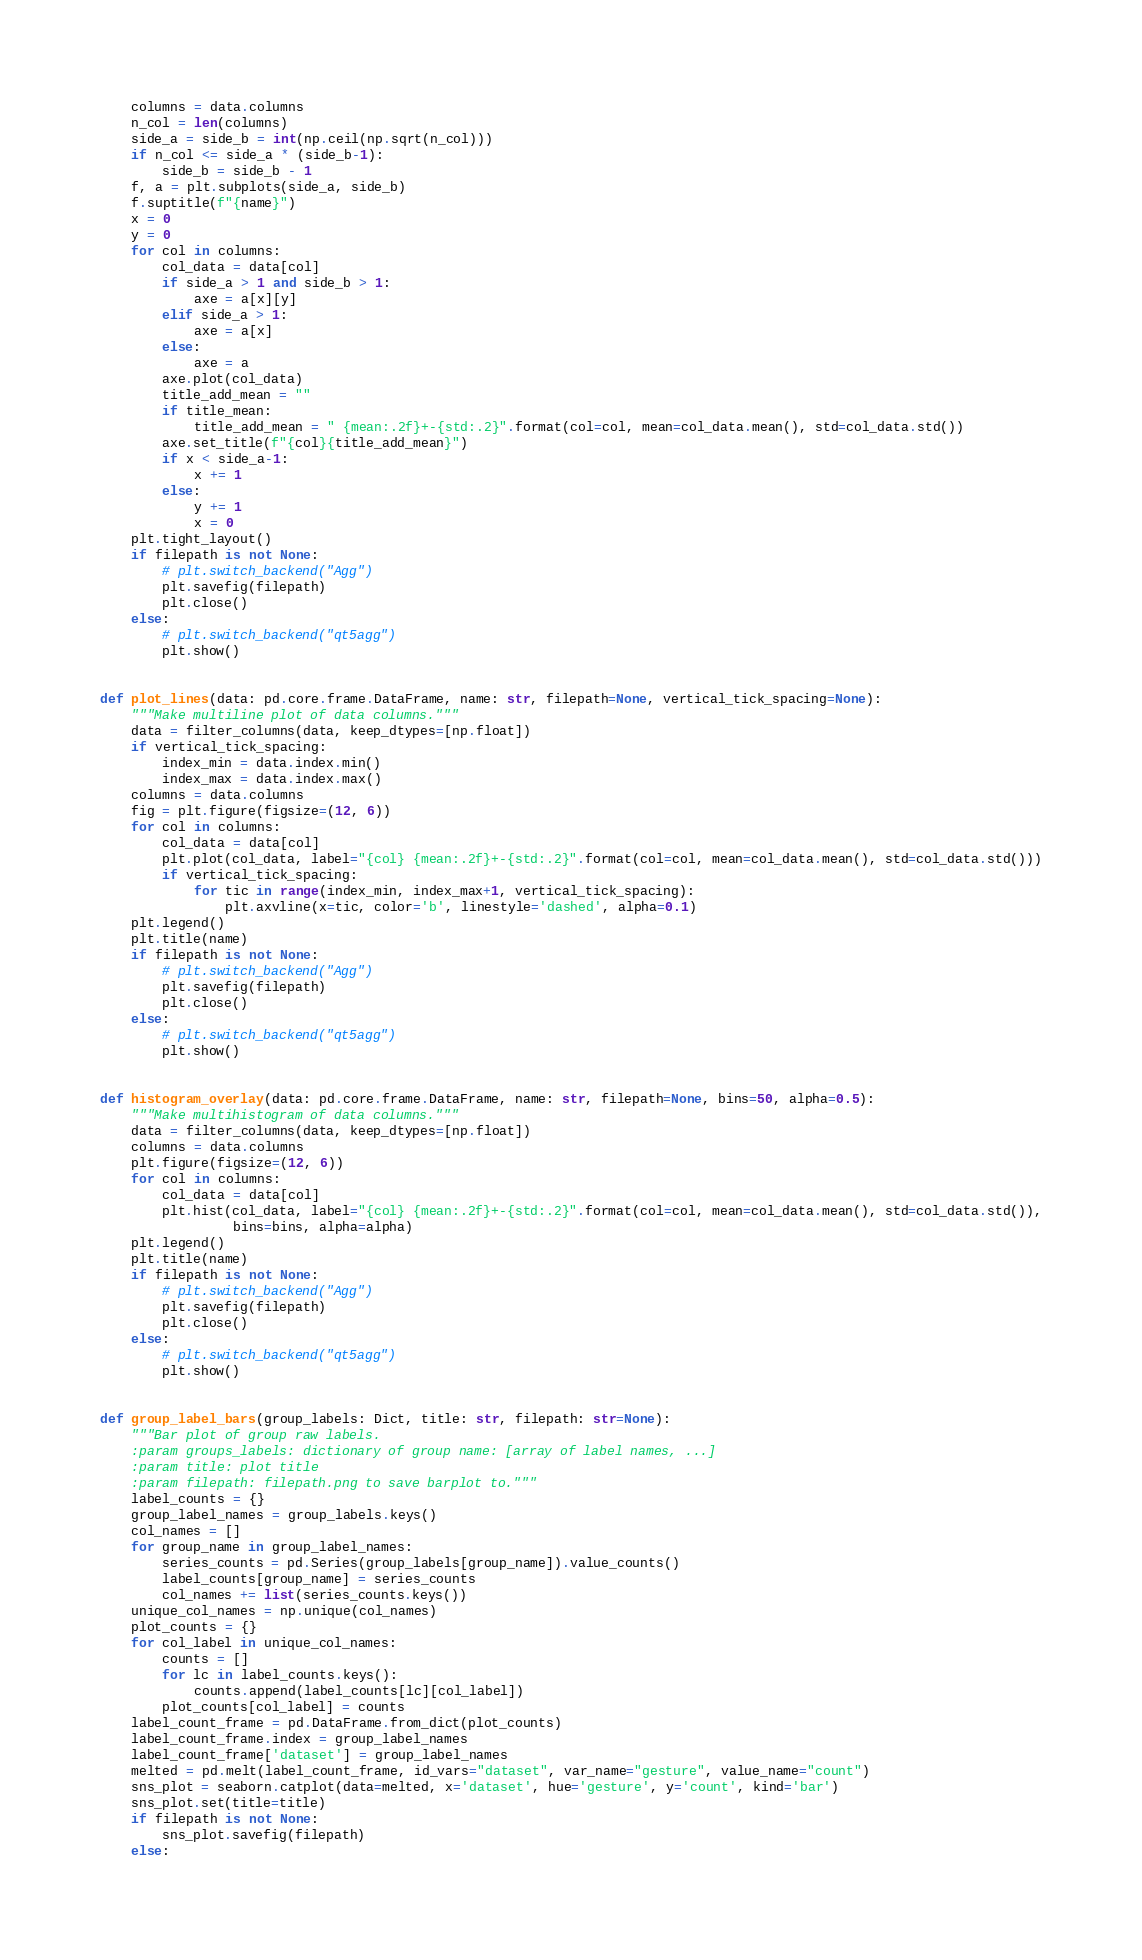<code> <loc_0><loc_0><loc_500><loc_500><_Python_>    columns = data.columns
    n_col = len(columns)
    side_a = side_b = int(np.ceil(np.sqrt(n_col)))
    if n_col <= side_a * (side_b-1):
        side_b = side_b - 1
    f, a = plt.subplots(side_a, side_b)
    f.suptitle(f"{name}")
    x = 0
    y = 0
    for col in columns:
        col_data = data[col]
        if side_a > 1 and side_b > 1:
            axe = a[x][y]
        elif side_a > 1:
            axe = a[x]
        else:
            axe = a
        axe.plot(col_data)
        title_add_mean = ""
        if title_mean:
            title_add_mean = " {mean:.2f}+-{std:.2}".format(col=col, mean=col_data.mean(), std=col_data.std())
        axe.set_title(f"{col}{title_add_mean}")
        if x < side_a-1:
            x += 1
        else:
            y += 1
            x = 0
    plt.tight_layout()
    if filepath is not None:
        # plt.switch_backend("Agg")
        plt.savefig(filepath)
        plt.close()
    else:
        # plt.switch_backend("qt5agg")
        plt.show()


def plot_lines(data: pd.core.frame.DataFrame, name: str, filepath=None, vertical_tick_spacing=None):
    """Make multiline plot of data columns."""
    data = filter_columns(data, keep_dtypes=[np.float])
    if vertical_tick_spacing:
        index_min = data.index.min()
        index_max = data.index.max()
    columns = data.columns
    fig = plt.figure(figsize=(12, 6))
    for col in columns:
        col_data = data[col]
        plt.plot(col_data, label="{col} {mean:.2f}+-{std:.2}".format(col=col, mean=col_data.mean(), std=col_data.std()))
        if vertical_tick_spacing:
            for tic in range(index_min, index_max+1, vertical_tick_spacing):
                plt.axvline(x=tic, color='b', linestyle='dashed', alpha=0.1)
    plt.legend()
    plt.title(name)
    if filepath is not None:
        # plt.switch_backend("Agg")
        plt.savefig(filepath)
        plt.close()
    else:
        # plt.switch_backend("qt5agg")
        plt.show()


def histogram_overlay(data: pd.core.frame.DataFrame, name: str, filepath=None, bins=50, alpha=0.5):
    """Make multihistogram of data columns."""
    data = filter_columns(data, keep_dtypes=[np.float])
    columns = data.columns
    plt.figure(figsize=(12, 6))
    for col in columns:
        col_data = data[col]
        plt.hist(col_data, label="{col} {mean:.2f}+-{std:.2}".format(col=col, mean=col_data.mean(), std=col_data.std()),
                 bins=bins, alpha=alpha)
    plt.legend()
    plt.title(name)
    if filepath is not None:
        # plt.switch_backend("Agg")
        plt.savefig(filepath)
        plt.close()
    else:
        # plt.switch_backend("qt5agg")
        plt.show()


def group_label_bars(group_labels: Dict, title: str, filepath: str=None):
    """Bar plot of group raw labels.
    :param groups_labels: dictionary of group name: [array of label names, ...]
    :param title: plot title
    :param filepath: filepath.png to save barplot to."""
    label_counts = {}
    group_label_names = group_labels.keys()
    col_names = []
    for group_name in group_label_names:
        series_counts = pd.Series(group_labels[group_name]).value_counts()
        label_counts[group_name] = series_counts
        col_names += list(series_counts.keys())
    unique_col_names = np.unique(col_names)
    plot_counts = {}
    for col_label in unique_col_names:
        counts = []
        for lc in label_counts.keys():
            counts.append(label_counts[lc][col_label])
        plot_counts[col_label] = counts
    label_count_frame = pd.DataFrame.from_dict(plot_counts)
    label_count_frame.index = group_label_names
    label_count_frame['dataset'] = group_label_names
    melted = pd.melt(label_count_frame, id_vars="dataset", var_name="gesture", value_name="count")
    sns_plot = seaborn.catplot(data=melted, x='dataset', hue='gesture', y='count', kind='bar')
    sns_plot.set(title=title)
    if filepath is not None:
        sns_plot.savefig(filepath)
    else:</code> 